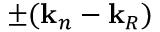Convert formula to latex. <formula><loc_0><loc_0><loc_500><loc_500>\pm ( k _ { n } - k _ { R } )</formula> 